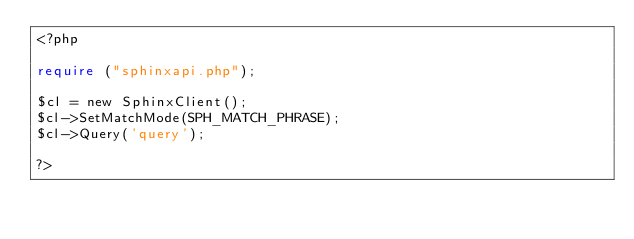<code> <loc_0><loc_0><loc_500><loc_500><_PHP_><?php

require ("sphinxapi.php");

$cl = new SphinxClient();
$cl->SetMatchMode(SPH_MATCH_PHRASE);
$cl->Query('query');

?></code> 